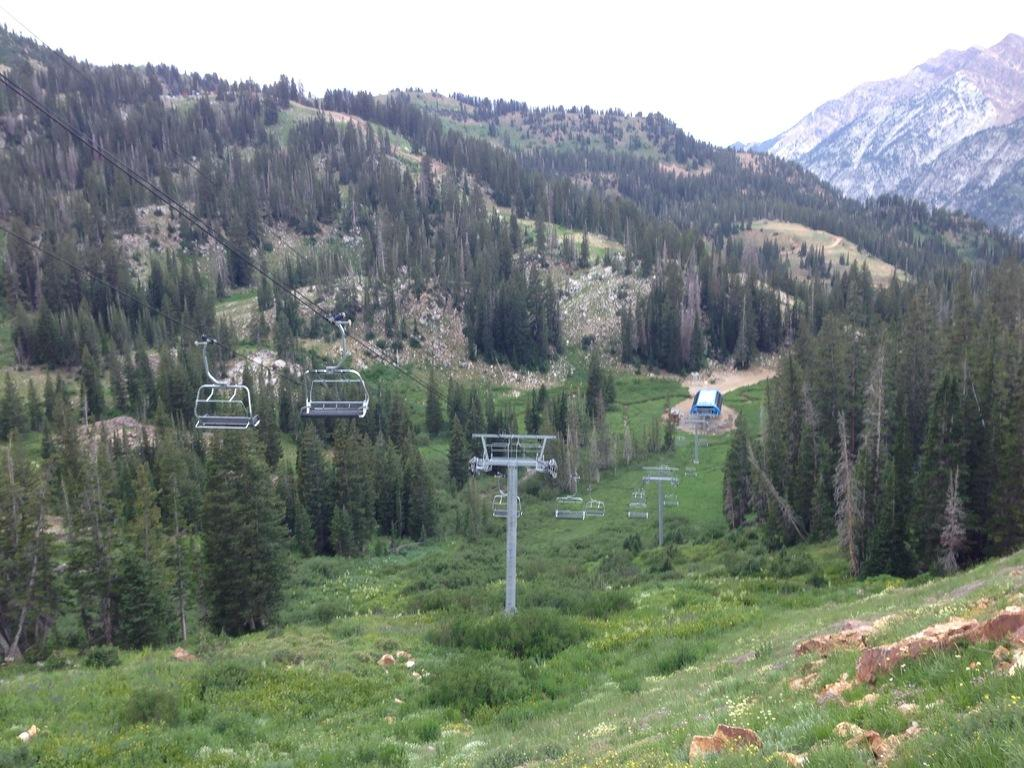What type of natural formation can be seen in the image? There are mountains in the image. What vegetation is present on the mountains? Trees are present on the mountains. What mode of transportation is visible in the image? There is a ropeway in the image. What supports the ropeway? The ropeway has poles. What is visible at the bottom of the image? Rocks and green grass are visible at the bottom of the image. Can you tell me how many goats are being helped by the ropeway in the image? There are no goats present in the image, nor is there any indication of them being helped by the ropeway. 